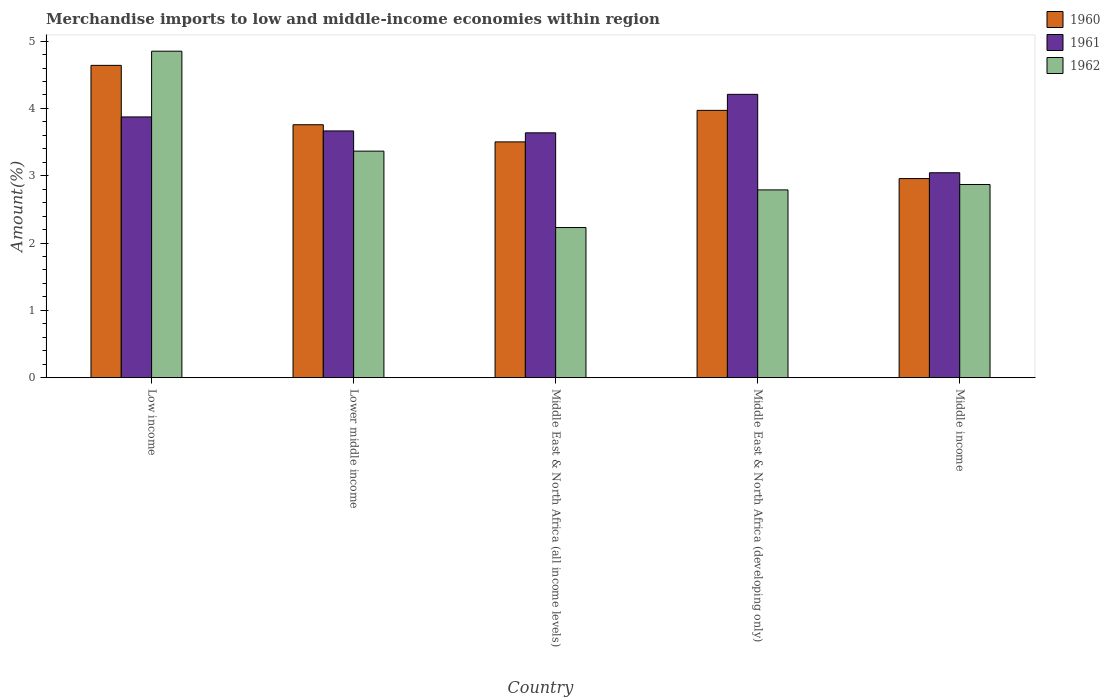How many bars are there on the 1st tick from the left?
Ensure brevity in your answer.  3. How many bars are there on the 2nd tick from the right?
Your response must be concise. 3. What is the label of the 4th group of bars from the left?
Your response must be concise. Middle East & North Africa (developing only). What is the percentage of amount earned from merchandise imports in 1961 in Low income?
Make the answer very short. 3.87. Across all countries, what is the maximum percentage of amount earned from merchandise imports in 1962?
Keep it short and to the point. 4.85. Across all countries, what is the minimum percentage of amount earned from merchandise imports in 1961?
Make the answer very short. 3.04. In which country was the percentage of amount earned from merchandise imports in 1961 maximum?
Your response must be concise. Middle East & North Africa (developing only). In which country was the percentage of amount earned from merchandise imports in 1960 minimum?
Make the answer very short. Middle income. What is the total percentage of amount earned from merchandise imports in 1960 in the graph?
Your answer should be very brief. 18.83. What is the difference between the percentage of amount earned from merchandise imports in 1960 in Middle East & North Africa (all income levels) and that in Middle East & North Africa (developing only)?
Keep it short and to the point. -0.47. What is the difference between the percentage of amount earned from merchandise imports in 1961 in Middle income and the percentage of amount earned from merchandise imports in 1962 in Middle East & North Africa (developing only)?
Offer a very short reply. 0.25. What is the average percentage of amount earned from merchandise imports in 1960 per country?
Provide a succinct answer. 3.77. What is the difference between the percentage of amount earned from merchandise imports of/in 1960 and percentage of amount earned from merchandise imports of/in 1961 in Low income?
Offer a terse response. 0.77. In how many countries, is the percentage of amount earned from merchandise imports in 1962 greater than 4.2 %?
Your answer should be very brief. 1. What is the ratio of the percentage of amount earned from merchandise imports in 1962 in Lower middle income to that in Middle East & North Africa (all income levels)?
Offer a very short reply. 1.51. Is the percentage of amount earned from merchandise imports in 1962 in Low income less than that in Middle income?
Your response must be concise. No. Is the difference between the percentage of amount earned from merchandise imports in 1960 in Low income and Middle East & North Africa (developing only) greater than the difference between the percentage of amount earned from merchandise imports in 1961 in Low income and Middle East & North Africa (developing only)?
Give a very brief answer. Yes. What is the difference between the highest and the second highest percentage of amount earned from merchandise imports in 1960?
Give a very brief answer. -0.21. What is the difference between the highest and the lowest percentage of amount earned from merchandise imports in 1962?
Give a very brief answer. 2.62. What does the 1st bar from the right in Middle East & North Africa (all income levels) represents?
Provide a short and direct response. 1962. Is it the case that in every country, the sum of the percentage of amount earned from merchandise imports in 1962 and percentage of amount earned from merchandise imports in 1960 is greater than the percentage of amount earned from merchandise imports in 1961?
Offer a very short reply. Yes. How many bars are there?
Offer a very short reply. 15. Are all the bars in the graph horizontal?
Your answer should be very brief. No. How many countries are there in the graph?
Your response must be concise. 5. Are the values on the major ticks of Y-axis written in scientific E-notation?
Make the answer very short. No. Does the graph contain any zero values?
Keep it short and to the point. No. Where does the legend appear in the graph?
Give a very brief answer. Top right. What is the title of the graph?
Give a very brief answer. Merchandise imports to low and middle-income economies within region. Does "1988" appear as one of the legend labels in the graph?
Make the answer very short. No. What is the label or title of the Y-axis?
Make the answer very short. Amount(%). What is the Amount(%) in 1960 in Low income?
Provide a short and direct response. 4.64. What is the Amount(%) of 1961 in Low income?
Provide a succinct answer. 3.87. What is the Amount(%) in 1962 in Low income?
Your response must be concise. 4.85. What is the Amount(%) of 1960 in Lower middle income?
Your answer should be very brief. 3.76. What is the Amount(%) of 1961 in Lower middle income?
Your answer should be very brief. 3.67. What is the Amount(%) in 1962 in Lower middle income?
Your answer should be compact. 3.37. What is the Amount(%) of 1960 in Middle East & North Africa (all income levels)?
Keep it short and to the point. 3.5. What is the Amount(%) of 1961 in Middle East & North Africa (all income levels)?
Offer a very short reply. 3.64. What is the Amount(%) in 1962 in Middle East & North Africa (all income levels)?
Offer a terse response. 2.23. What is the Amount(%) in 1960 in Middle East & North Africa (developing only)?
Your response must be concise. 3.97. What is the Amount(%) of 1961 in Middle East & North Africa (developing only)?
Offer a very short reply. 4.21. What is the Amount(%) in 1962 in Middle East & North Africa (developing only)?
Ensure brevity in your answer.  2.79. What is the Amount(%) of 1960 in Middle income?
Provide a succinct answer. 2.96. What is the Amount(%) of 1961 in Middle income?
Your response must be concise. 3.04. What is the Amount(%) in 1962 in Middle income?
Ensure brevity in your answer.  2.87. Across all countries, what is the maximum Amount(%) in 1960?
Your answer should be very brief. 4.64. Across all countries, what is the maximum Amount(%) of 1961?
Offer a terse response. 4.21. Across all countries, what is the maximum Amount(%) of 1962?
Give a very brief answer. 4.85. Across all countries, what is the minimum Amount(%) in 1960?
Your response must be concise. 2.96. Across all countries, what is the minimum Amount(%) in 1961?
Your answer should be very brief. 3.04. Across all countries, what is the minimum Amount(%) of 1962?
Keep it short and to the point. 2.23. What is the total Amount(%) of 1960 in the graph?
Your response must be concise. 18.83. What is the total Amount(%) of 1961 in the graph?
Make the answer very short. 18.43. What is the total Amount(%) in 1962 in the graph?
Keep it short and to the point. 16.11. What is the difference between the Amount(%) in 1960 in Low income and that in Lower middle income?
Offer a terse response. 0.88. What is the difference between the Amount(%) of 1961 in Low income and that in Lower middle income?
Provide a short and direct response. 0.21. What is the difference between the Amount(%) in 1962 in Low income and that in Lower middle income?
Make the answer very short. 1.48. What is the difference between the Amount(%) of 1960 in Low income and that in Middle East & North Africa (all income levels)?
Provide a short and direct response. 1.14. What is the difference between the Amount(%) of 1961 in Low income and that in Middle East & North Africa (all income levels)?
Make the answer very short. 0.24. What is the difference between the Amount(%) in 1962 in Low income and that in Middle East & North Africa (all income levels)?
Provide a short and direct response. 2.62. What is the difference between the Amount(%) in 1960 in Low income and that in Middle East & North Africa (developing only)?
Keep it short and to the point. 0.67. What is the difference between the Amount(%) in 1961 in Low income and that in Middle East & North Africa (developing only)?
Your answer should be very brief. -0.34. What is the difference between the Amount(%) in 1962 in Low income and that in Middle East & North Africa (developing only)?
Provide a short and direct response. 2.06. What is the difference between the Amount(%) of 1960 in Low income and that in Middle income?
Your answer should be compact. 1.68. What is the difference between the Amount(%) of 1961 in Low income and that in Middle income?
Provide a short and direct response. 0.83. What is the difference between the Amount(%) in 1962 in Low income and that in Middle income?
Provide a short and direct response. 1.98. What is the difference between the Amount(%) of 1960 in Lower middle income and that in Middle East & North Africa (all income levels)?
Your answer should be very brief. 0.25. What is the difference between the Amount(%) in 1961 in Lower middle income and that in Middle East & North Africa (all income levels)?
Provide a succinct answer. 0.03. What is the difference between the Amount(%) in 1962 in Lower middle income and that in Middle East & North Africa (all income levels)?
Provide a short and direct response. 1.14. What is the difference between the Amount(%) of 1960 in Lower middle income and that in Middle East & North Africa (developing only)?
Offer a very short reply. -0.21. What is the difference between the Amount(%) of 1961 in Lower middle income and that in Middle East & North Africa (developing only)?
Ensure brevity in your answer.  -0.54. What is the difference between the Amount(%) of 1962 in Lower middle income and that in Middle East & North Africa (developing only)?
Offer a very short reply. 0.58. What is the difference between the Amount(%) of 1960 in Lower middle income and that in Middle income?
Your answer should be compact. 0.8. What is the difference between the Amount(%) of 1961 in Lower middle income and that in Middle income?
Offer a very short reply. 0.62. What is the difference between the Amount(%) in 1962 in Lower middle income and that in Middle income?
Ensure brevity in your answer.  0.5. What is the difference between the Amount(%) of 1960 in Middle East & North Africa (all income levels) and that in Middle East & North Africa (developing only)?
Offer a very short reply. -0.47. What is the difference between the Amount(%) in 1961 in Middle East & North Africa (all income levels) and that in Middle East & North Africa (developing only)?
Make the answer very short. -0.57. What is the difference between the Amount(%) of 1962 in Middle East & North Africa (all income levels) and that in Middle East & North Africa (developing only)?
Your answer should be compact. -0.56. What is the difference between the Amount(%) in 1960 in Middle East & North Africa (all income levels) and that in Middle income?
Give a very brief answer. 0.55. What is the difference between the Amount(%) in 1961 in Middle East & North Africa (all income levels) and that in Middle income?
Make the answer very short. 0.59. What is the difference between the Amount(%) in 1962 in Middle East & North Africa (all income levels) and that in Middle income?
Your response must be concise. -0.64. What is the difference between the Amount(%) in 1960 in Middle East & North Africa (developing only) and that in Middle income?
Keep it short and to the point. 1.01. What is the difference between the Amount(%) of 1961 in Middle East & North Africa (developing only) and that in Middle income?
Your answer should be very brief. 1.16. What is the difference between the Amount(%) of 1962 in Middle East & North Africa (developing only) and that in Middle income?
Provide a succinct answer. -0.08. What is the difference between the Amount(%) of 1960 in Low income and the Amount(%) of 1961 in Lower middle income?
Provide a short and direct response. 0.97. What is the difference between the Amount(%) in 1960 in Low income and the Amount(%) in 1962 in Lower middle income?
Offer a terse response. 1.27. What is the difference between the Amount(%) of 1961 in Low income and the Amount(%) of 1962 in Lower middle income?
Provide a short and direct response. 0.51. What is the difference between the Amount(%) of 1960 in Low income and the Amount(%) of 1962 in Middle East & North Africa (all income levels)?
Offer a terse response. 2.41. What is the difference between the Amount(%) in 1961 in Low income and the Amount(%) in 1962 in Middle East & North Africa (all income levels)?
Ensure brevity in your answer.  1.64. What is the difference between the Amount(%) of 1960 in Low income and the Amount(%) of 1961 in Middle East & North Africa (developing only)?
Provide a short and direct response. 0.43. What is the difference between the Amount(%) in 1960 in Low income and the Amount(%) in 1962 in Middle East & North Africa (developing only)?
Your answer should be compact. 1.85. What is the difference between the Amount(%) in 1961 in Low income and the Amount(%) in 1962 in Middle East & North Africa (developing only)?
Make the answer very short. 1.08. What is the difference between the Amount(%) in 1960 in Low income and the Amount(%) in 1961 in Middle income?
Your answer should be compact. 1.6. What is the difference between the Amount(%) of 1960 in Low income and the Amount(%) of 1962 in Middle income?
Make the answer very short. 1.77. What is the difference between the Amount(%) of 1961 in Low income and the Amount(%) of 1962 in Middle income?
Your answer should be very brief. 1. What is the difference between the Amount(%) in 1960 in Lower middle income and the Amount(%) in 1961 in Middle East & North Africa (all income levels)?
Ensure brevity in your answer.  0.12. What is the difference between the Amount(%) of 1960 in Lower middle income and the Amount(%) of 1962 in Middle East & North Africa (all income levels)?
Keep it short and to the point. 1.53. What is the difference between the Amount(%) in 1961 in Lower middle income and the Amount(%) in 1962 in Middle East & North Africa (all income levels)?
Your response must be concise. 1.44. What is the difference between the Amount(%) of 1960 in Lower middle income and the Amount(%) of 1961 in Middle East & North Africa (developing only)?
Provide a succinct answer. -0.45. What is the difference between the Amount(%) in 1961 in Lower middle income and the Amount(%) in 1962 in Middle East & North Africa (developing only)?
Provide a succinct answer. 0.88. What is the difference between the Amount(%) of 1960 in Lower middle income and the Amount(%) of 1961 in Middle income?
Give a very brief answer. 0.71. What is the difference between the Amount(%) in 1960 in Lower middle income and the Amount(%) in 1962 in Middle income?
Provide a succinct answer. 0.89. What is the difference between the Amount(%) in 1961 in Lower middle income and the Amount(%) in 1962 in Middle income?
Your response must be concise. 0.8. What is the difference between the Amount(%) in 1960 in Middle East & North Africa (all income levels) and the Amount(%) in 1961 in Middle East & North Africa (developing only)?
Make the answer very short. -0.71. What is the difference between the Amount(%) of 1960 in Middle East & North Africa (all income levels) and the Amount(%) of 1962 in Middle East & North Africa (developing only)?
Give a very brief answer. 0.71. What is the difference between the Amount(%) of 1961 in Middle East & North Africa (all income levels) and the Amount(%) of 1962 in Middle East & North Africa (developing only)?
Give a very brief answer. 0.85. What is the difference between the Amount(%) in 1960 in Middle East & North Africa (all income levels) and the Amount(%) in 1961 in Middle income?
Offer a very short reply. 0.46. What is the difference between the Amount(%) in 1960 in Middle East & North Africa (all income levels) and the Amount(%) in 1962 in Middle income?
Your response must be concise. 0.63. What is the difference between the Amount(%) in 1961 in Middle East & North Africa (all income levels) and the Amount(%) in 1962 in Middle income?
Your response must be concise. 0.77. What is the difference between the Amount(%) in 1960 in Middle East & North Africa (developing only) and the Amount(%) in 1961 in Middle income?
Offer a very short reply. 0.93. What is the difference between the Amount(%) of 1960 in Middle East & North Africa (developing only) and the Amount(%) of 1962 in Middle income?
Give a very brief answer. 1.1. What is the difference between the Amount(%) of 1961 in Middle East & North Africa (developing only) and the Amount(%) of 1962 in Middle income?
Offer a terse response. 1.34. What is the average Amount(%) of 1960 per country?
Keep it short and to the point. 3.77. What is the average Amount(%) in 1961 per country?
Offer a terse response. 3.69. What is the average Amount(%) in 1962 per country?
Offer a terse response. 3.22. What is the difference between the Amount(%) in 1960 and Amount(%) in 1961 in Low income?
Offer a terse response. 0.77. What is the difference between the Amount(%) of 1960 and Amount(%) of 1962 in Low income?
Give a very brief answer. -0.21. What is the difference between the Amount(%) of 1961 and Amount(%) of 1962 in Low income?
Your response must be concise. -0.98. What is the difference between the Amount(%) of 1960 and Amount(%) of 1961 in Lower middle income?
Give a very brief answer. 0.09. What is the difference between the Amount(%) of 1960 and Amount(%) of 1962 in Lower middle income?
Keep it short and to the point. 0.39. What is the difference between the Amount(%) in 1961 and Amount(%) in 1962 in Lower middle income?
Give a very brief answer. 0.3. What is the difference between the Amount(%) in 1960 and Amount(%) in 1961 in Middle East & North Africa (all income levels)?
Ensure brevity in your answer.  -0.13. What is the difference between the Amount(%) in 1960 and Amount(%) in 1962 in Middle East & North Africa (all income levels)?
Ensure brevity in your answer.  1.27. What is the difference between the Amount(%) of 1961 and Amount(%) of 1962 in Middle East & North Africa (all income levels)?
Your answer should be very brief. 1.41. What is the difference between the Amount(%) in 1960 and Amount(%) in 1961 in Middle East & North Africa (developing only)?
Ensure brevity in your answer.  -0.24. What is the difference between the Amount(%) in 1960 and Amount(%) in 1962 in Middle East & North Africa (developing only)?
Keep it short and to the point. 1.18. What is the difference between the Amount(%) of 1961 and Amount(%) of 1962 in Middle East & North Africa (developing only)?
Keep it short and to the point. 1.42. What is the difference between the Amount(%) in 1960 and Amount(%) in 1961 in Middle income?
Your answer should be very brief. -0.09. What is the difference between the Amount(%) of 1960 and Amount(%) of 1962 in Middle income?
Offer a terse response. 0.09. What is the difference between the Amount(%) of 1961 and Amount(%) of 1962 in Middle income?
Your response must be concise. 0.17. What is the ratio of the Amount(%) in 1960 in Low income to that in Lower middle income?
Offer a very short reply. 1.23. What is the ratio of the Amount(%) in 1961 in Low income to that in Lower middle income?
Keep it short and to the point. 1.06. What is the ratio of the Amount(%) of 1962 in Low income to that in Lower middle income?
Offer a very short reply. 1.44. What is the ratio of the Amount(%) of 1960 in Low income to that in Middle East & North Africa (all income levels)?
Offer a very short reply. 1.32. What is the ratio of the Amount(%) of 1961 in Low income to that in Middle East & North Africa (all income levels)?
Keep it short and to the point. 1.06. What is the ratio of the Amount(%) in 1962 in Low income to that in Middle East & North Africa (all income levels)?
Provide a succinct answer. 2.17. What is the ratio of the Amount(%) of 1960 in Low income to that in Middle East & North Africa (developing only)?
Your answer should be very brief. 1.17. What is the ratio of the Amount(%) in 1961 in Low income to that in Middle East & North Africa (developing only)?
Give a very brief answer. 0.92. What is the ratio of the Amount(%) of 1962 in Low income to that in Middle East & North Africa (developing only)?
Your response must be concise. 1.74. What is the ratio of the Amount(%) in 1960 in Low income to that in Middle income?
Provide a short and direct response. 1.57. What is the ratio of the Amount(%) of 1961 in Low income to that in Middle income?
Keep it short and to the point. 1.27. What is the ratio of the Amount(%) of 1962 in Low income to that in Middle income?
Give a very brief answer. 1.69. What is the ratio of the Amount(%) of 1960 in Lower middle income to that in Middle East & North Africa (all income levels)?
Your response must be concise. 1.07. What is the ratio of the Amount(%) of 1961 in Lower middle income to that in Middle East & North Africa (all income levels)?
Offer a very short reply. 1.01. What is the ratio of the Amount(%) of 1962 in Lower middle income to that in Middle East & North Africa (all income levels)?
Ensure brevity in your answer.  1.51. What is the ratio of the Amount(%) in 1960 in Lower middle income to that in Middle East & North Africa (developing only)?
Give a very brief answer. 0.95. What is the ratio of the Amount(%) of 1961 in Lower middle income to that in Middle East & North Africa (developing only)?
Offer a very short reply. 0.87. What is the ratio of the Amount(%) in 1962 in Lower middle income to that in Middle East & North Africa (developing only)?
Offer a terse response. 1.21. What is the ratio of the Amount(%) of 1960 in Lower middle income to that in Middle income?
Your answer should be very brief. 1.27. What is the ratio of the Amount(%) of 1961 in Lower middle income to that in Middle income?
Offer a terse response. 1.2. What is the ratio of the Amount(%) of 1962 in Lower middle income to that in Middle income?
Keep it short and to the point. 1.17. What is the ratio of the Amount(%) of 1960 in Middle East & North Africa (all income levels) to that in Middle East & North Africa (developing only)?
Provide a short and direct response. 0.88. What is the ratio of the Amount(%) in 1961 in Middle East & North Africa (all income levels) to that in Middle East & North Africa (developing only)?
Make the answer very short. 0.86. What is the ratio of the Amount(%) in 1962 in Middle East & North Africa (all income levels) to that in Middle East & North Africa (developing only)?
Your response must be concise. 0.8. What is the ratio of the Amount(%) in 1960 in Middle East & North Africa (all income levels) to that in Middle income?
Offer a terse response. 1.18. What is the ratio of the Amount(%) of 1961 in Middle East & North Africa (all income levels) to that in Middle income?
Keep it short and to the point. 1.19. What is the ratio of the Amount(%) in 1962 in Middle East & North Africa (all income levels) to that in Middle income?
Make the answer very short. 0.78. What is the ratio of the Amount(%) of 1960 in Middle East & North Africa (developing only) to that in Middle income?
Your answer should be very brief. 1.34. What is the ratio of the Amount(%) of 1961 in Middle East & North Africa (developing only) to that in Middle income?
Your answer should be compact. 1.38. What is the ratio of the Amount(%) in 1962 in Middle East & North Africa (developing only) to that in Middle income?
Provide a short and direct response. 0.97. What is the difference between the highest and the second highest Amount(%) of 1960?
Give a very brief answer. 0.67. What is the difference between the highest and the second highest Amount(%) of 1961?
Offer a terse response. 0.34. What is the difference between the highest and the second highest Amount(%) in 1962?
Your answer should be very brief. 1.48. What is the difference between the highest and the lowest Amount(%) of 1960?
Keep it short and to the point. 1.68. What is the difference between the highest and the lowest Amount(%) in 1961?
Your response must be concise. 1.16. What is the difference between the highest and the lowest Amount(%) of 1962?
Your answer should be very brief. 2.62. 